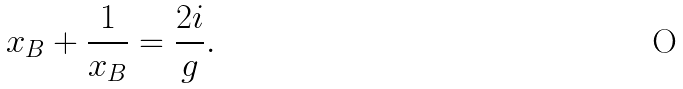Convert formula to latex. <formula><loc_0><loc_0><loc_500><loc_500>x _ { B } + \frac { 1 } { x _ { B } } = \frac { 2 i } { g } .</formula> 